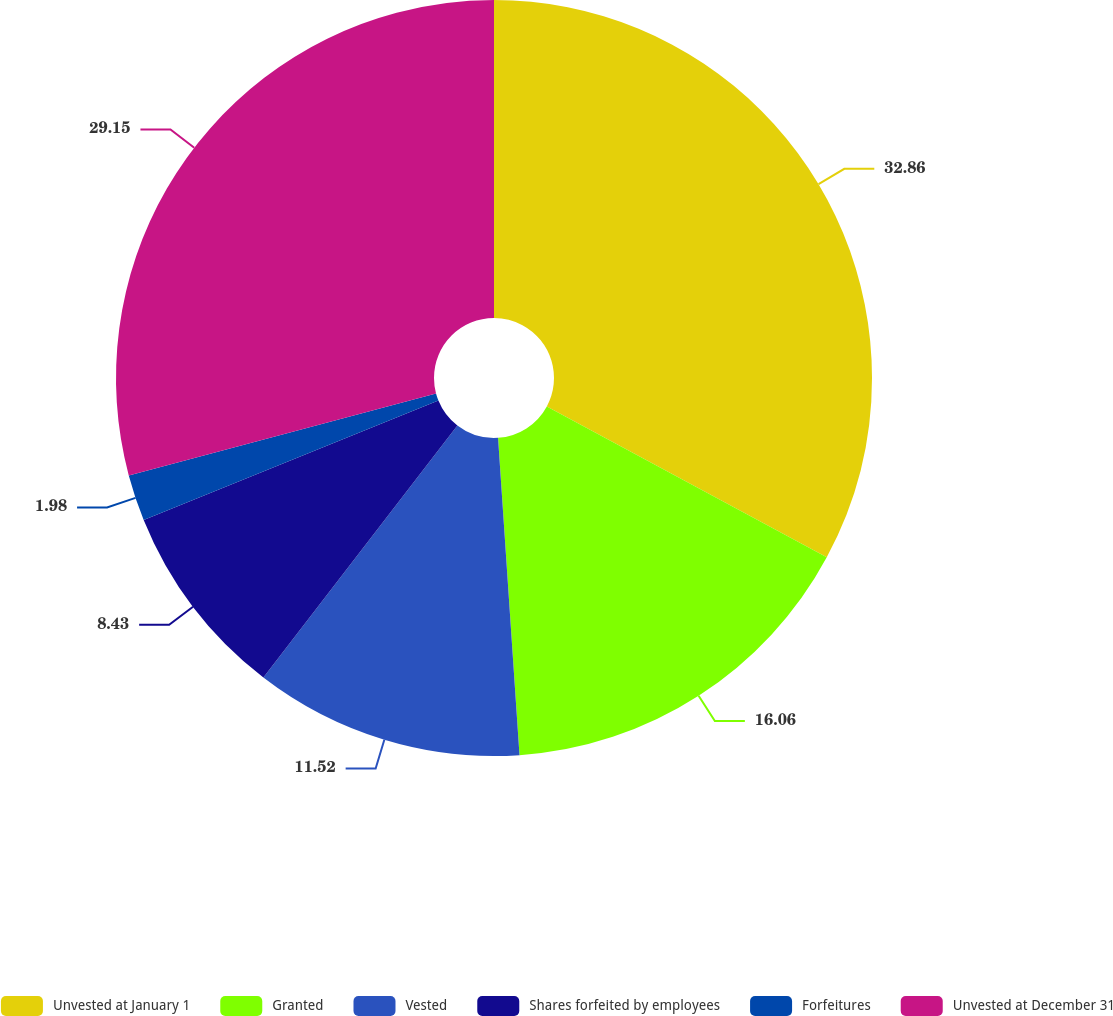Convert chart to OTSL. <chart><loc_0><loc_0><loc_500><loc_500><pie_chart><fcel>Unvested at January 1<fcel>Granted<fcel>Vested<fcel>Shares forfeited by employees<fcel>Forfeitures<fcel>Unvested at December 31<nl><fcel>32.87%<fcel>16.06%<fcel>11.52%<fcel>8.43%<fcel>1.98%<fcel>29.15%<nl></chart> 